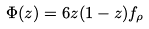Convert formula to latex. <formula><loc_0><loc_0><loc_500><loc_500>\Phi ( z ) = 6 z ( 1 - z ) f _ { \rho }</formula> 